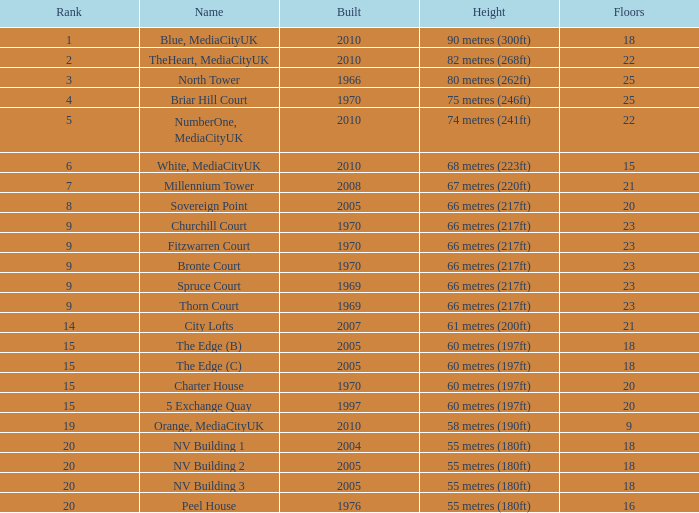What is the total number of Built, when Floors is less than 22, when Rank is less than 8, and when Name is White, Mediacityuk? 1.0. 